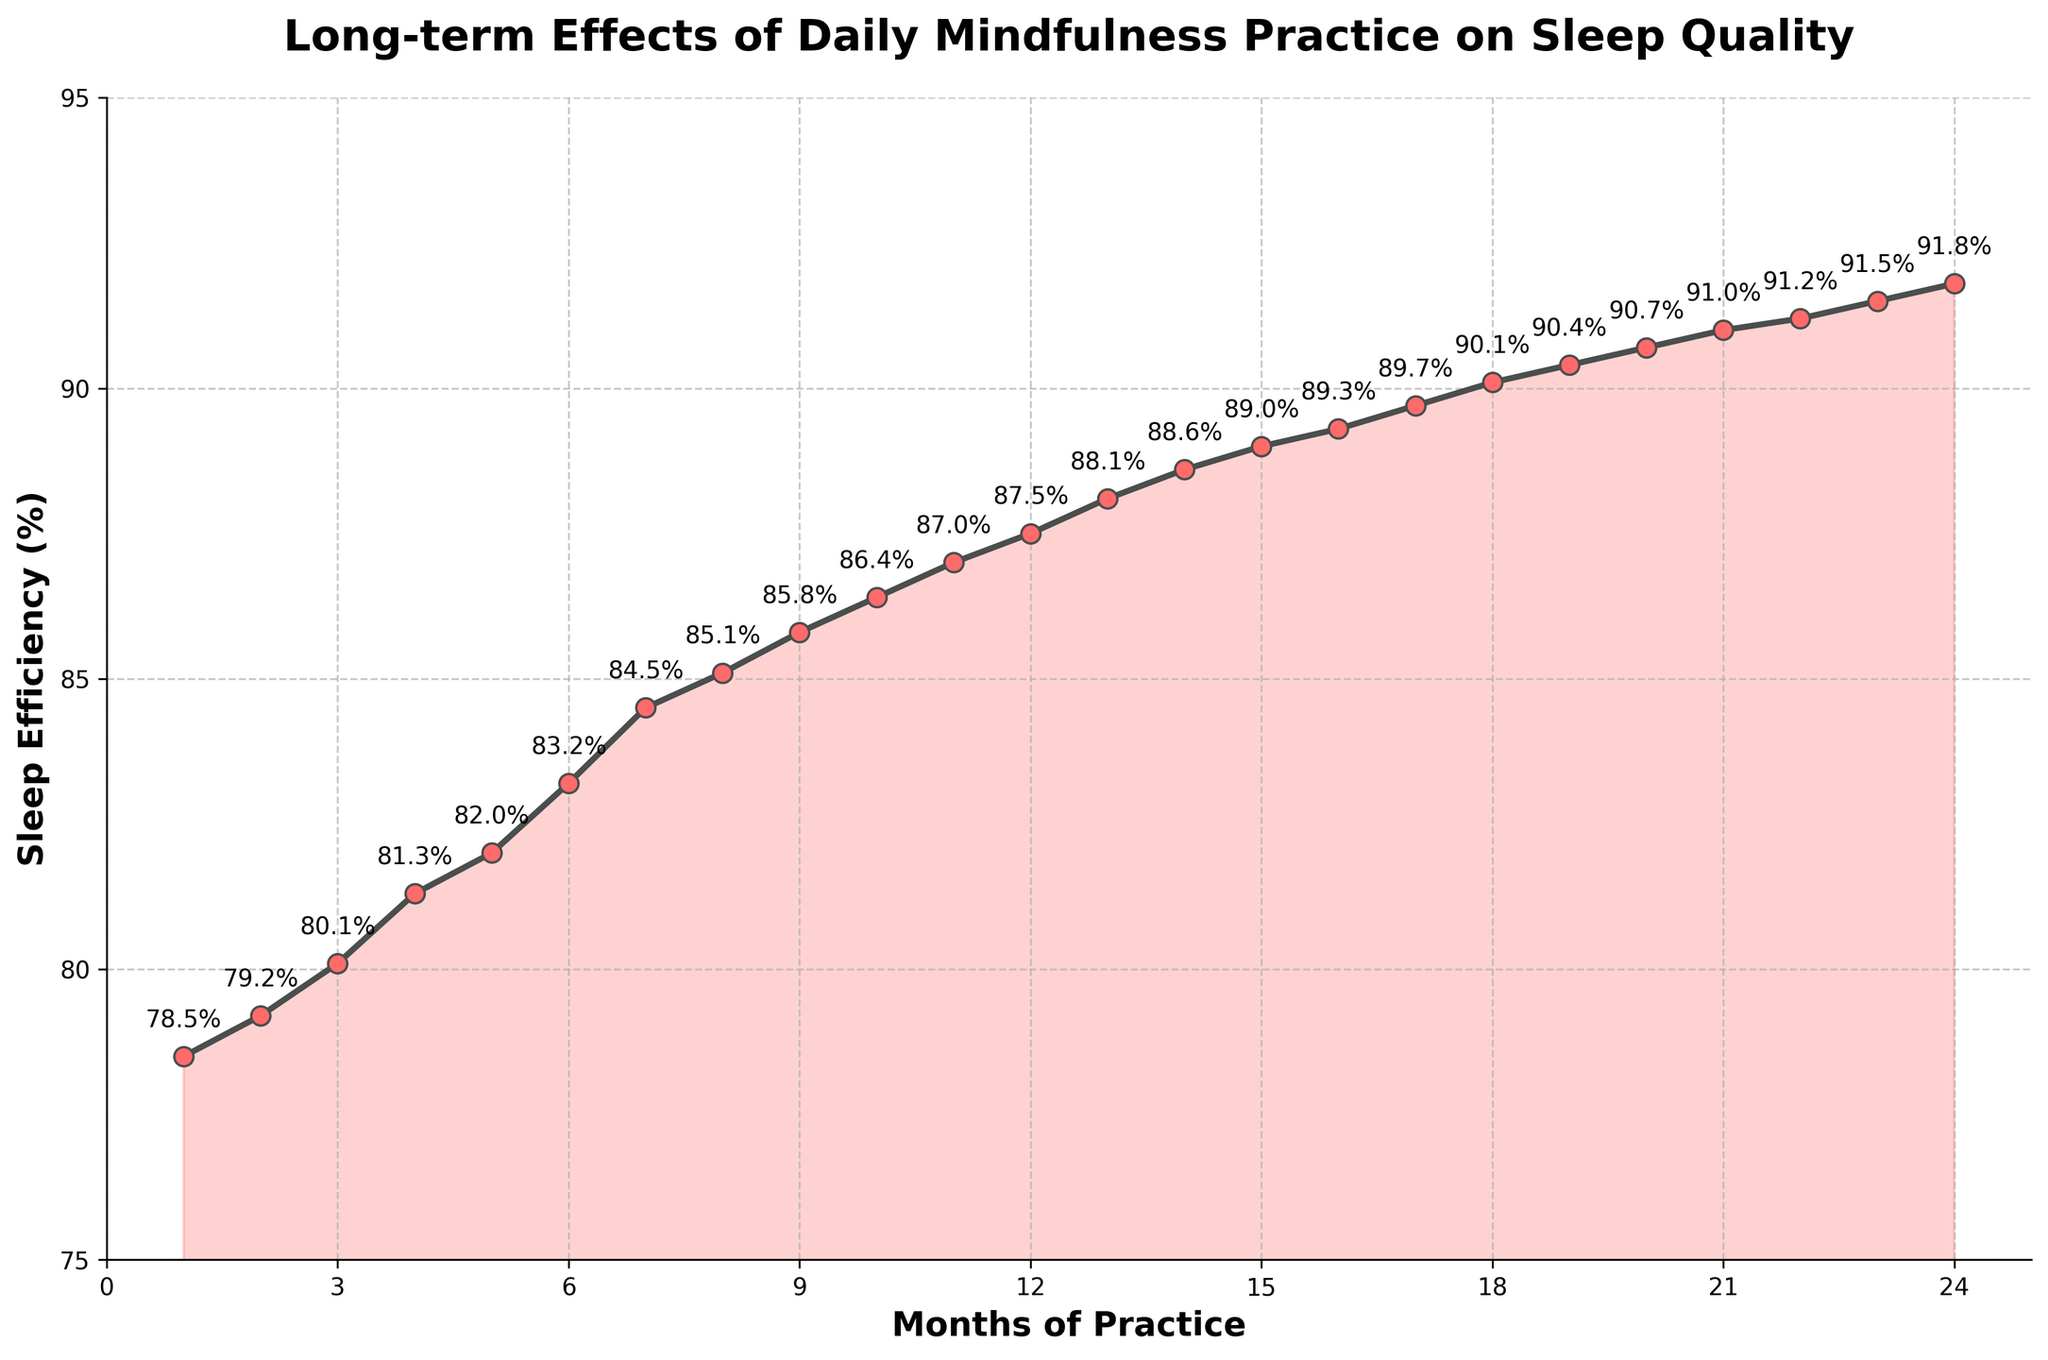What's the sleep efficiency percentage at the 12th month? By referring to the plot and looking at the point corresponding to the 12th month on the x-axis, we see that the sleep efficiency is labeled as 87.5%.
Answer: 87.5% Between which months does the sleep efficiency increase by 2.5 percentage points? To find the intervals where the increase is 2.5 percentage points, we need to look for the months where the difference in sleep efficiency is close to 2.5. Between the 6th month (83.2%) and the 8th month (85.1%), the sleep efficiency increases by 1.9 percentage points, and so on. Careful assessment shows none of the month pairs exactly match 2.5 percentage points increase.
Answer: None What is the average sleep efficiency over the first 6 months? The percentages for the first 6 months are: 78.5, 79.2, 80.1, 81.3, 82.0, and 83.2. Summing these: 78.5 + 79.2 + 80.1 + 81.3 + 82.0 + 83.2 = 484.3. Dividing this sum by 6 gives us the average: 484.3 / 6 = 80.72.
Answer: 80.72 By how much does the sleep efficiency percentage increase from the 1st month to the 24th month? The sleep efficiency at the 1st month is 78.5% and at the 24th month is 91.8%, so the increase is 91.8 - 78.5 = 13.3 percentage points.
Answer: 13.3 Which month sees the smallest increase in sleep efficiency from the previous month? To find this, look at the differences between consecutive months. The smallest increase occurs between the 22nd month (91.2%) and the 23rd month (91.5%), which is 91.5 - 91.2 = 0.3 percentage points.
Answer: Between 22nd and 23rd month Do any months show a decrease in sleep efficiency? By inspecting the entire line chart, we see that the trend is continuously upward without any dips, so no month shows a decrease in sleep efficiency.
Answer: No Is the slope of the sleep efficiency curve steeper at the beginning or towards the end? Visually, the initial months show a steeper upward trend in sleep efficiency compared to the latter months where the curve starts to flatten, suggesting the slope is steeper at the beginning.
Answer: At the beginning 